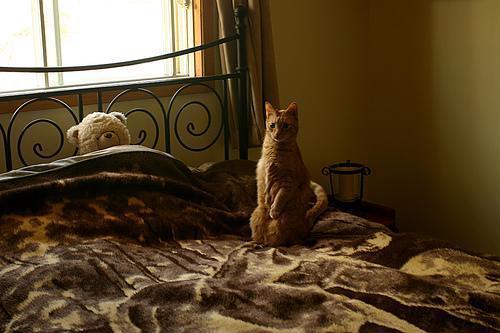How many cats are there?
Give a very brief answer. 1. 